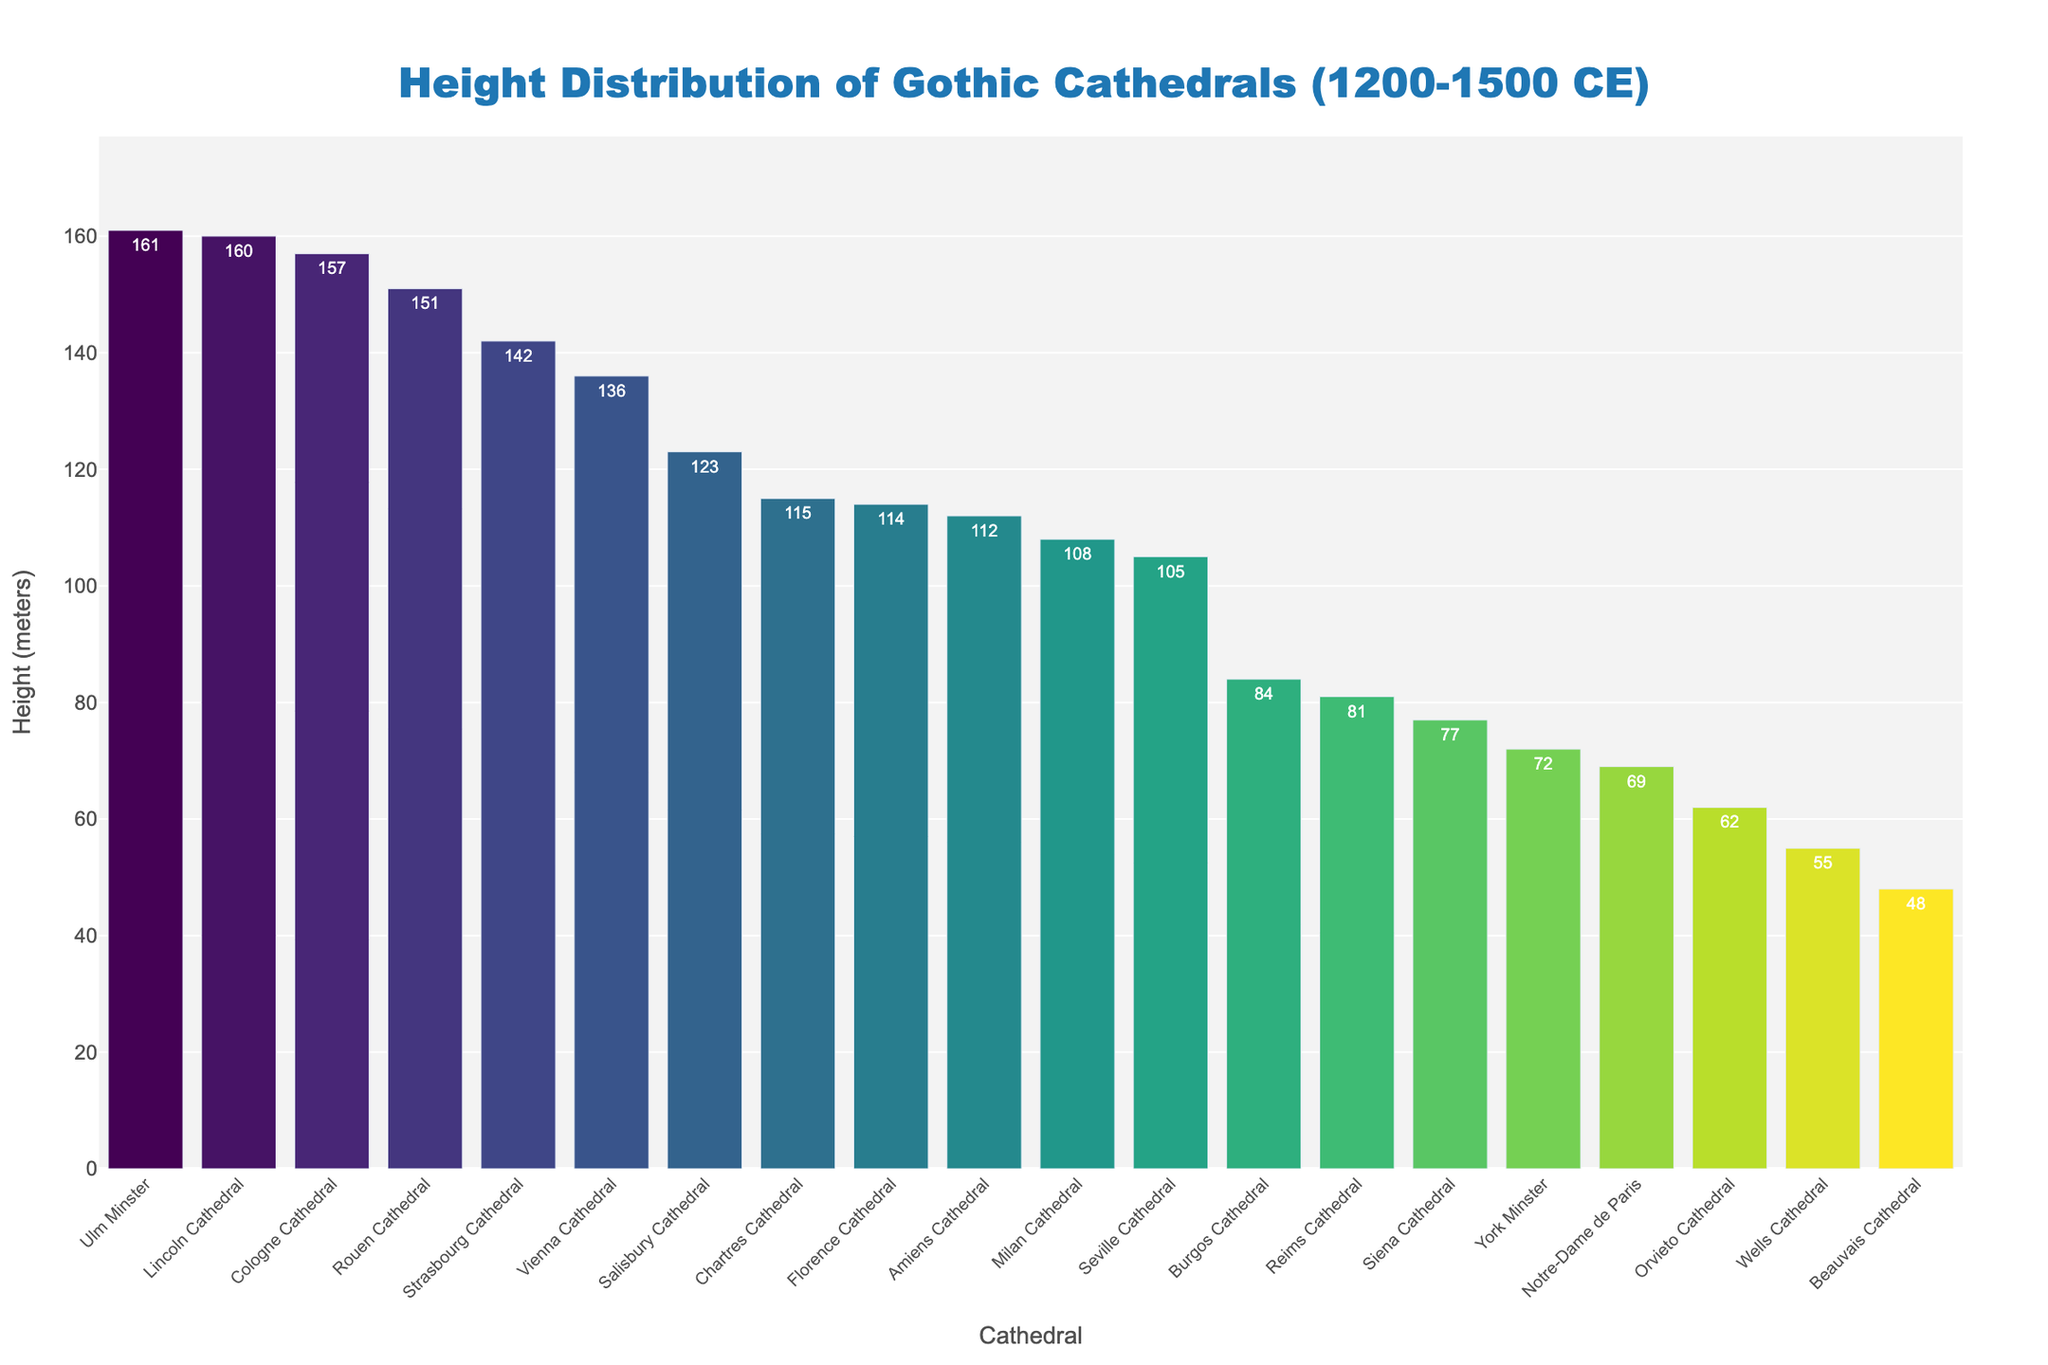Which cathedral is the tallest? The tallest cathedral can be identified by finding the bar that extends the highest along the y-axis.
Answer: Ulm Minster What is the height difference between Lincoln Cathedral and Strasbourg Cathedral? Lincoln Cathedral's height is 160 meters, and Strasbourg Cathedral's height is 142 meters. Subtract 142 from 160 to get the height difference.
Answer: 18 meters How many cathedrals are taller than 100 meters? Identify and count the bars that extend beyond the 100-meter mark on the y-axis.
Answer: 10 Which cathedral has a height closest to the average height of all cathedrals? First, calculate the average height by summing all heights and dividing by the number of cathedrals. Then, identify the cathedral whose height is closest to this average.
Answer: Seville Cathedral (closest to 100.55 meters) What's the median height of these cathedrals? Sort the heights in ascending order and find the middle value (or the average of the two middle values if there's an even number of data points).
Answer: 108 meters Which cathedral's height is the third highest? Identify the heights in descending order and find the third highest value.
Answer: Rouen Cathedral Compare the heights of Notre-Dame de Paris and Cologne Cathedral. Which one is taller? Locate the bars representing Notre-Dame de Paris and Cologne Cathedral and compare their heights.
Answer: Cologne Cathedral What's the total height of Reims Cathedral, Chartres Cathedral, and Amiens Cathedral combined? Add the heights of Reims Cathedral (81 meters), Chartres Cathedral (115 meters), and Amiens Cathedral (112 meters).
Answer: 308 meters Are there more cathedrals below 70 meters or above 140 meters? Count the number of cathedrals with heights below 70 meters and those with heights above 140 meters and compare the counts.
Answer: Below 70 meters (3 vs 2) 